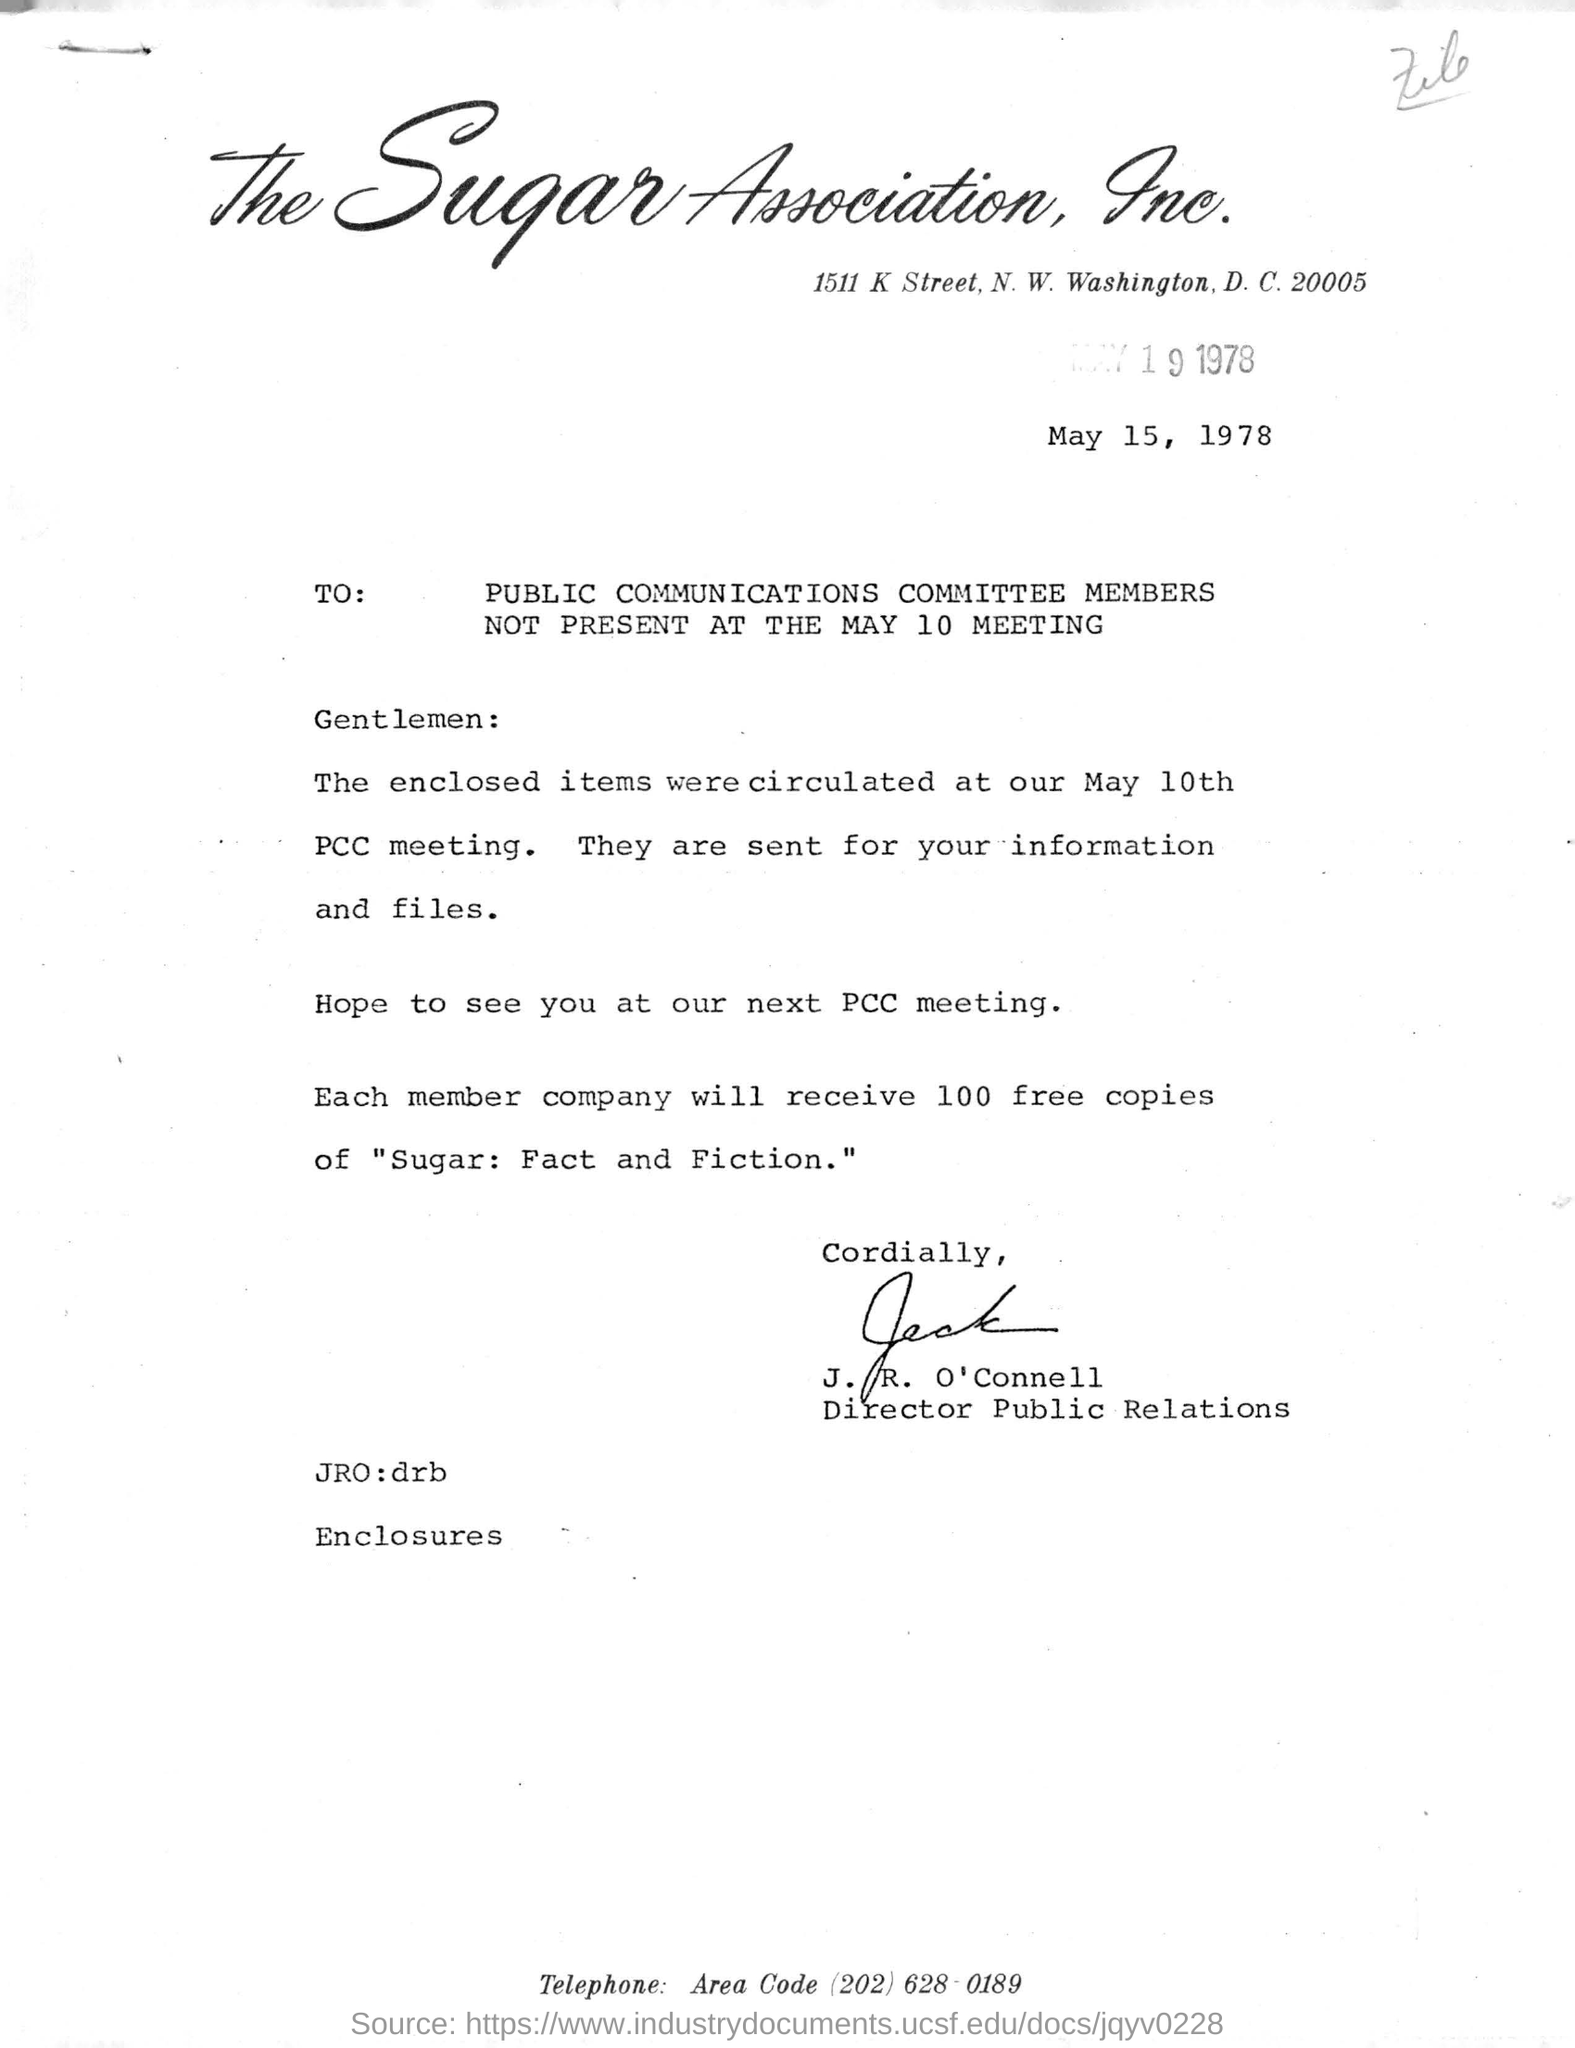Give some essential details in this illustration. Each member company will receive 100 free copies of the book 'Sugar: Fact and Fiction'. The sender of this letter is Director Public Relations. The letter is addressed to the Public Communications Committee members who were not present at the MAY 10 meeting. John R. O'Connell holds the designation of Director of Public Relations. 